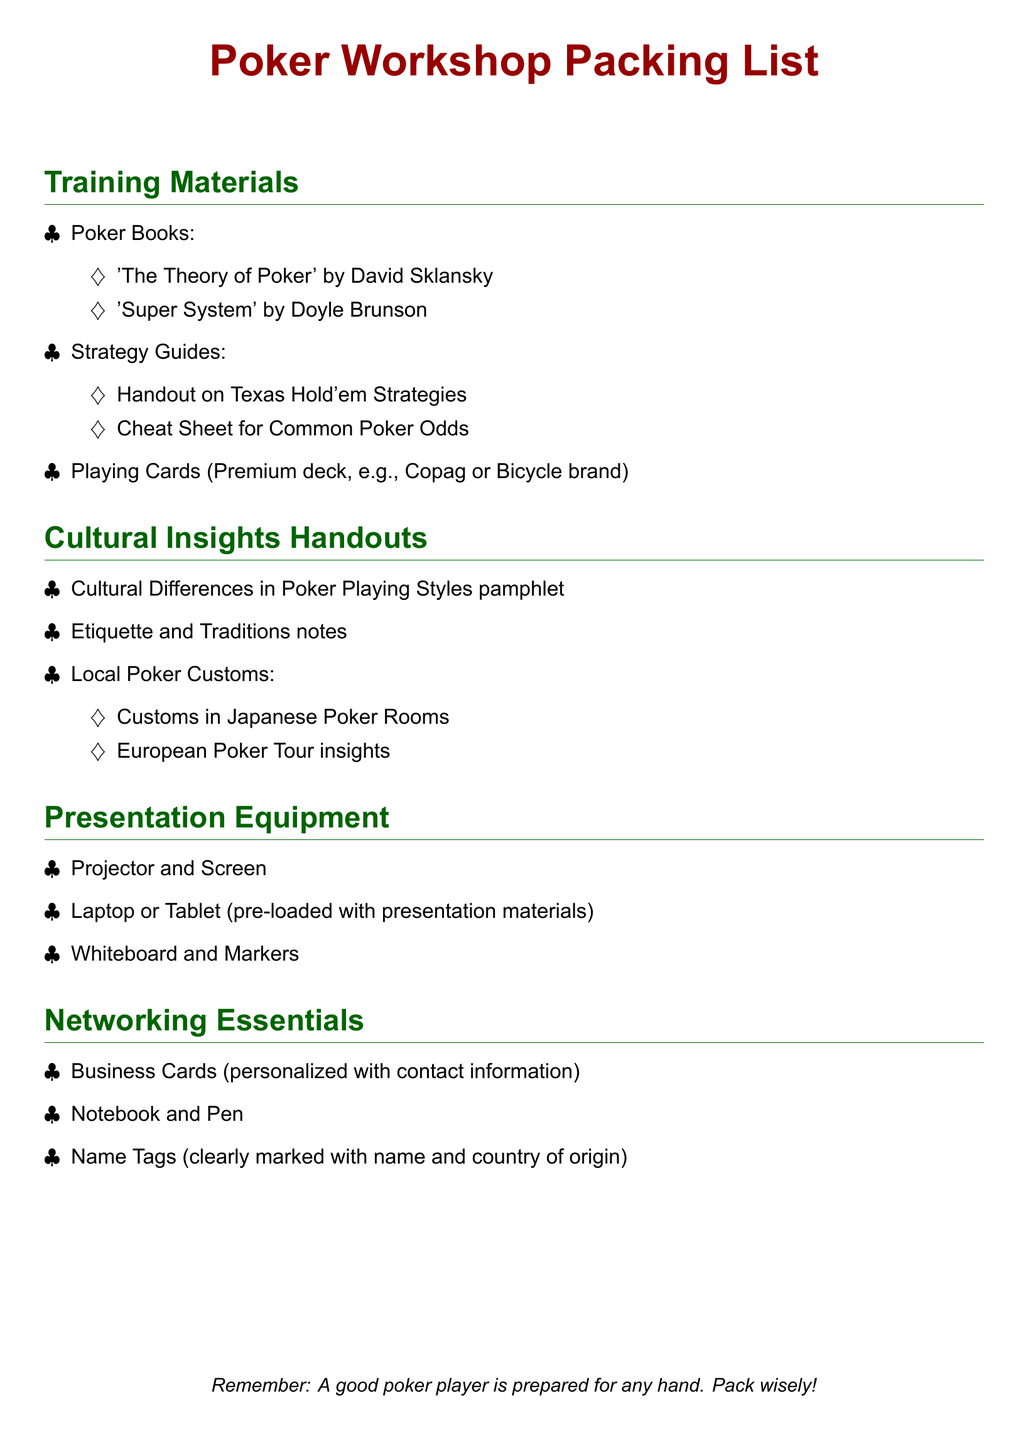What are some examples of poker books included? The document lists specific poker books under training materials, including notable titles.
Answer: 'The Theory of Poker', 'Super System' What is included in the cultural insights handouts? The document outlines specific items that comprise the cultural insights handouts.
Answer: Cultural Differences in Poker Playing Styles pamphlet What type of playing cards are recommended? The document specifies a premium deck of playing cards recommended for the workshop.
Answer: Premium deck How many strategy guides are mentioned? The document mentions a specific number of strategy guides under training materials.
Answer: Two What should be clearly marked on the name tags? The document specifies an important detail that should be included on the name tags for networking.
Answer: Name and country of origin What kind of materials should be pre-loaded on the laptop? The document describes what should be prepared on the laptop or tablet for the workshop.
Answer: Presentation materials What is one type of networking essential listed? The document provides examples of items considered networking essentials for the event.
Answer: Business Cards What type of screen is mentioned for presentation equipment? The document specifies the type of screen that is required as part of the presentation equipment.
Answer: Projector and Screen 